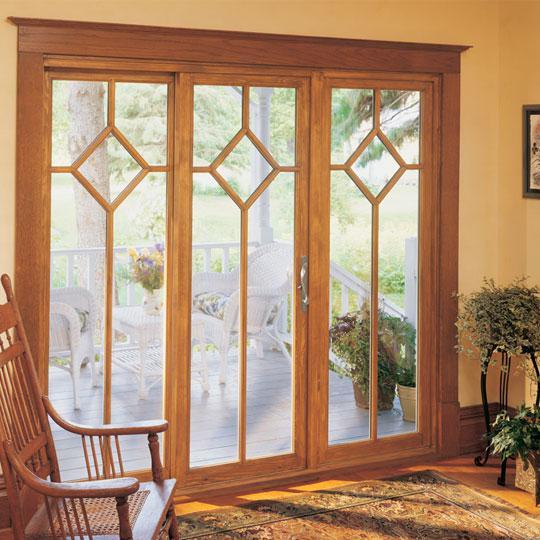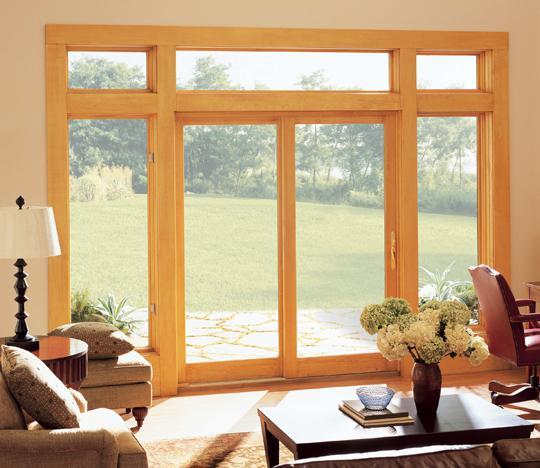The first image is the image on the left, the second image is the image on the right. For the images displayed, is the sentence "There is a flower vase on top of a table near a sliding door." factually correct? Answer yes or no. Yes. The first image is the image on the left, the second image is the image on the right. For the images displayed, is the sentence "An image shows a nearly square sliding door unit, with one door partly open, less than a quarter of the way." factually correct? Answer yes or no. No. 